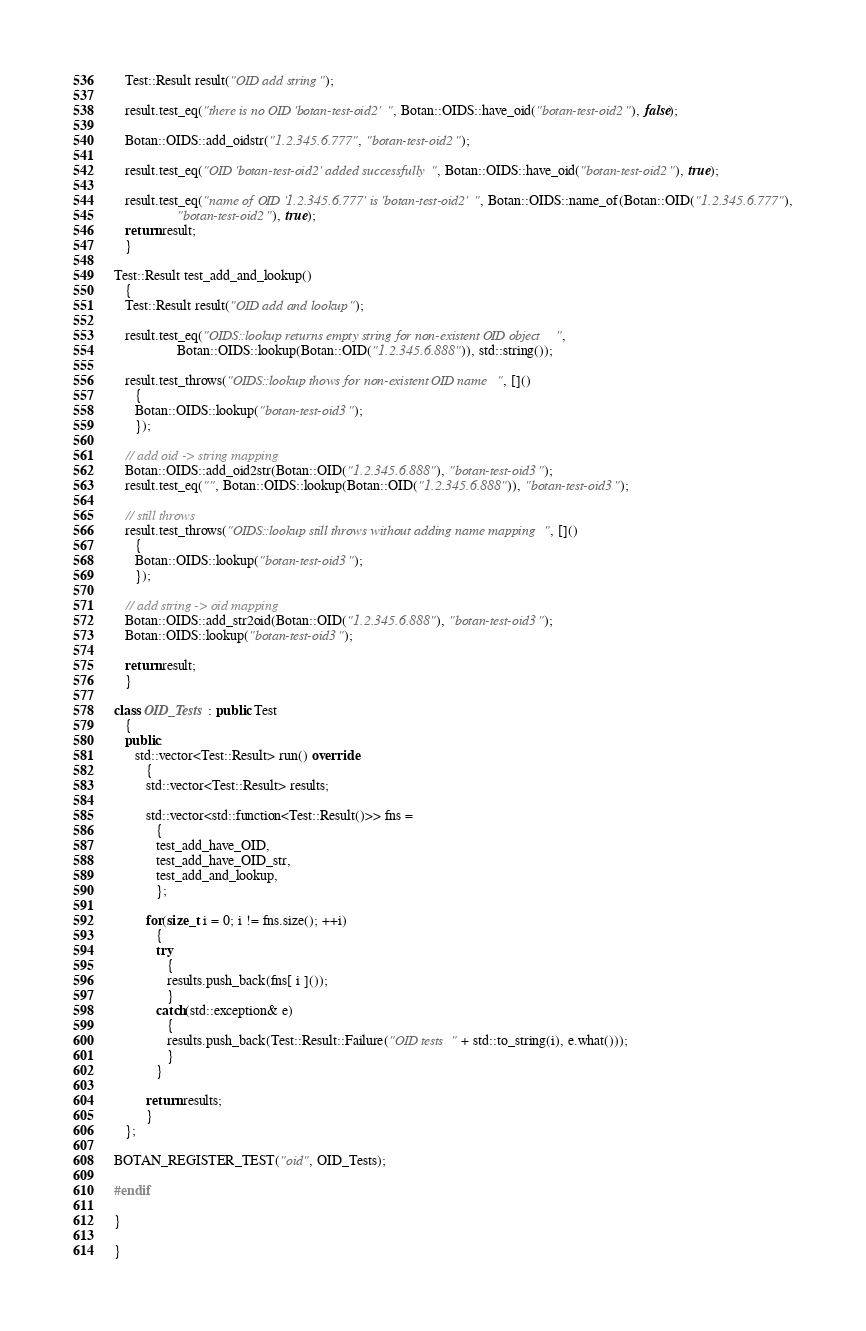<code> <loc_0><loc_0><loc_500><loc_500><_C++_>   Test::Result result("OID add string");

   result.test_eq("there is no OID 'botan-test-oid2'", Botan::OIDS::have_oid("botan-test-oid2"), false);

   Botan::OIDS::add_oidstr("1.2.345.6.777", "botan-test-oid2");

   result.test_eq("OID 'botan-test-oid2' added successfully", Botan::OIDS::have_oid("botan-test-oid2"), true);

   result.test_eq("name of OID '1.2.345.6.777' is 'botan-test-oid2'", Botan::OIDS::name_of(Botan::OID("1.2.345.6.777"),
                  "botan-test-oid2"), true);
   return result;
   }

Test::Result test_add_and_lookup()
   {
   Test::Result result("OID add and lookup");

   result.test_eq("OIDS::lookup returns empty string for non-existent OID object",
                  Botan::OIDS::lookup(Botan::OID("1.2.345.6.888")), std::string());

   result.test_throws("OIDS::lookup thows for non-existent OID name", []()
      {
      Botan::OIDS::lookup("botan-test-oid3");
      });

   // add oid -> string mapping
   Botan::OIDS::add_oid2str(Botan::OID("1.2.345.6.888"), "botan-test-oid3");
   result.test_eq("", Botan::OIDS::lookup(Botan::OID("1.2.345.6.888")), "botan-test-oid3");

   // still throws
   result.test_throws("OIDS::lookup still throws without adding name mapping", []()
      {
      Botan::OIDS::lookup("botan-test-oid3");
      });

   // add string -> oid mapping
   Botan::OIDS::add_str2oid(Botan::OID("1.2.345.6.888"), "botan-test-oid3");
   Botan::OIDS::lookup("botan-test-oid3");

   return result;
   }

class OID_Tests : public Test
   {
   public:
      std::vector<Test::Result> run() override
         {
         std::vector<Test::Result> results;

         std::vector<std::function<Test::Result()>> fns =
            {
            test_add_have_OID,
            test_add_have_OID_str,
            test_add_and_lookup,
            };

         for(size_t i = 0; i != fns.size(); ++i)
            {
            try
               {
               results.push_back(fns[ i ]());
               }
            catch(std::exception& e)
               {
               results.push_back(Test::Result::Failure("OID tests " + std::to_string(i), e.what()));
               }
            }

         return results;
         }
   };

BOTAN_REGISTER_TEST("oid", OID_Tests);

#endif

}

}
</code> 